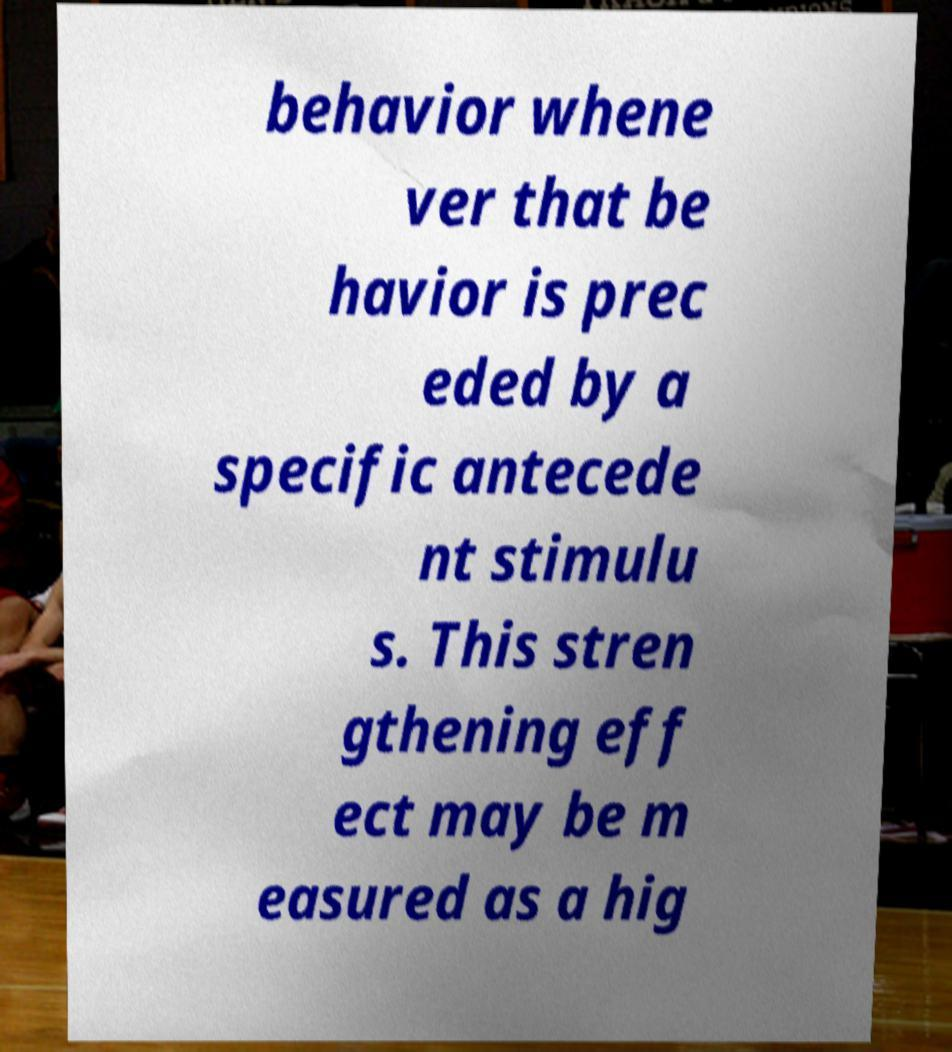Could you assist in decoding the text presented in this image and type it out clearly? behavior whene ver that be havior is prec eded by a specific antecede nt stimulu s. This stren gthening eff ect may be m easured as a hig 